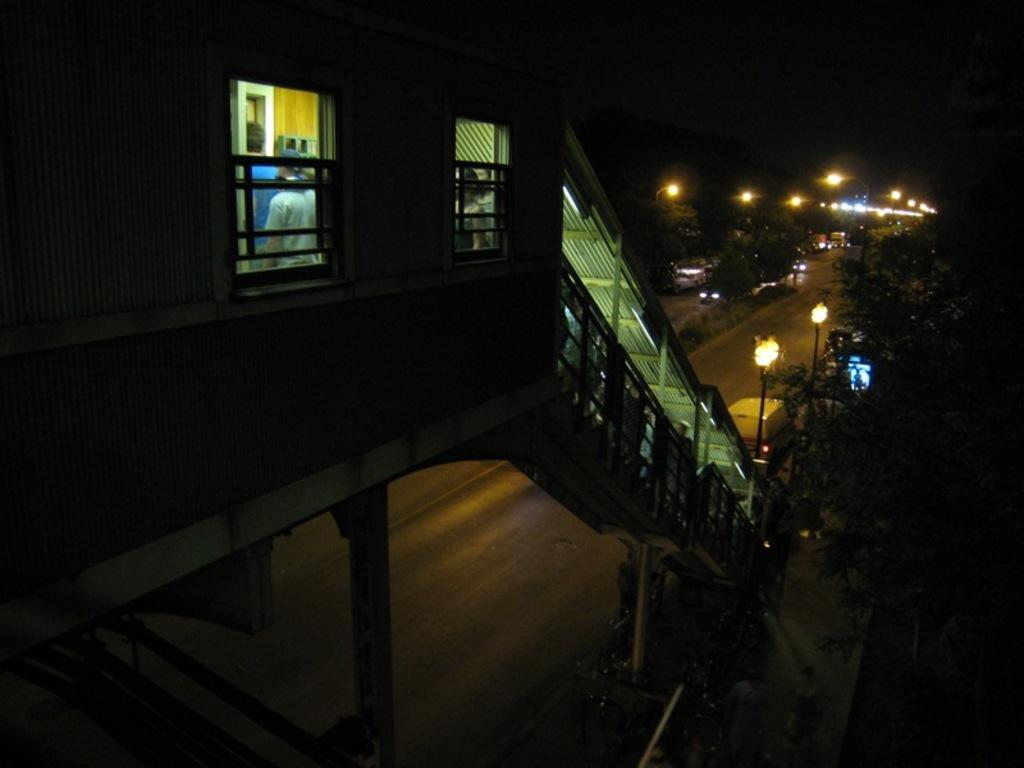What is the lighting condition in the image? The image is taken in the dark. Who or what can be seen in the image? There are people in the image. What architectural feature is present in the image? There are stairs in the image. What type of street furniture is visible in the image? There are light poles in the image. What type of vegetation is present in the image? There are trees in the image. What type of pathway is present in the image? There is a road in the image in the image. What is the color of the sky in the background of the image? The sky in the background is dark. What type of invention is being demonstrated in the image? There is no invention being demonstrated in the image; it features people, stairs, light poles, trees, a road, and a dark sky. What type of flesh can be seen on the people in the image? There is no need to describe the flesh of the people in the image, as it is not relevant to the main subjects and objects. 